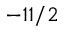Convert formula to latex. <formula><loc_0><loc_0><loc_500><loc_500>- 1 1 / 2</formula> 